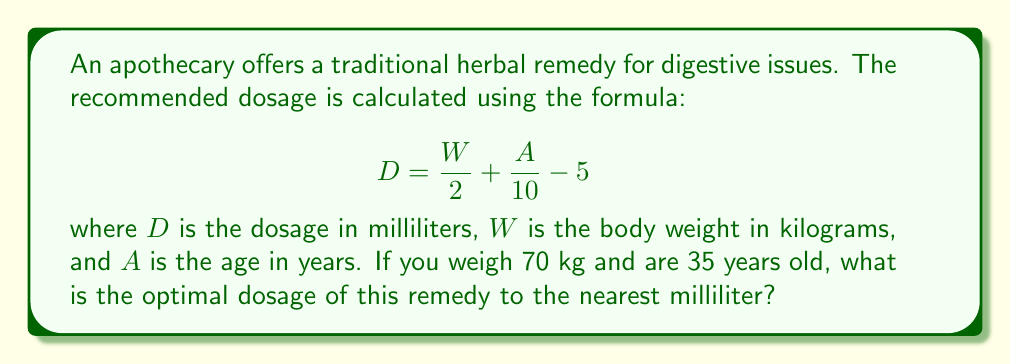Could you help me with this problem? To solve this problem, we'll follow these steps:

1) We are given the formula:
   $$ D = \frac{W}{2} + \frac{A}{10} - 5 $$

2) We know that:
   $W = 70$ kg (body weight)
   $A = 35$ years (age)

3) Let's substitute these values into the formula:
   $$ D = \frac{70}{2} + \frac{35}{10} - 5 $$

4) Now, let's calculate each part:
   $\frac{70}{2} = 35$
   $\frac{35}{10} = 3.5$

5) Substituting these calculated values:
   $$ D = 35 + 3.5 - 5 $$

6) Performing the addition and subtraction:
   $$ D = 38.5 - 5 = 33.5 $$

7) The question asks for the answer to the nearest milliliter, so we round 33.5 to 34.

Therefore, the optimal dosage is 34 milliliters.
Answer: 34 mL 